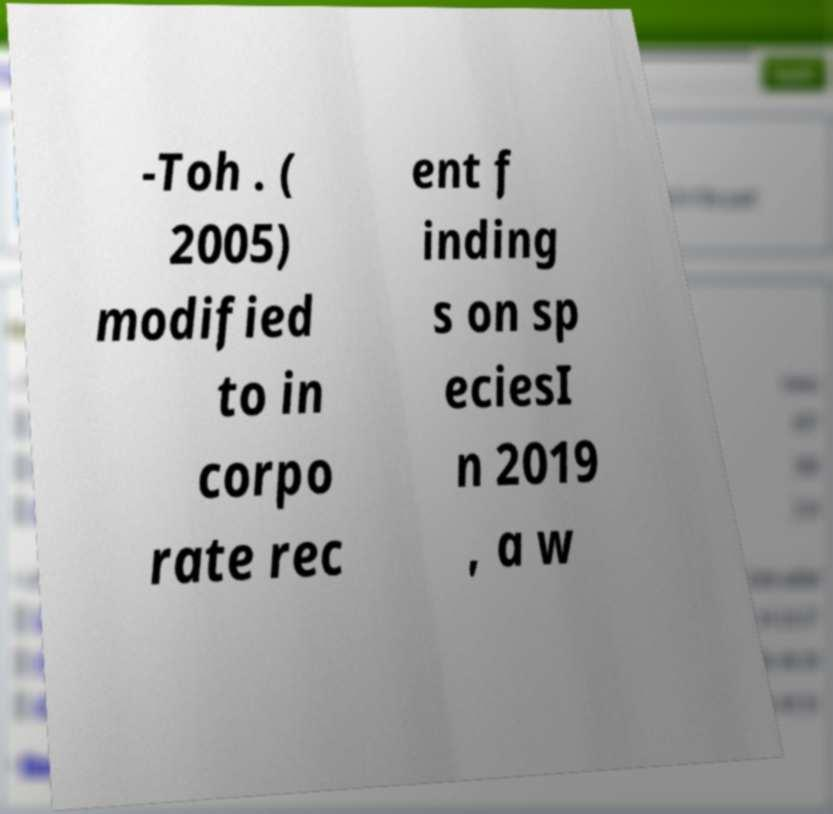Please read and relay the text visible in this image. What does it say? -Toh . ( 2005) modified to in corpo rate rec ent f inding s on sp eciesI n 2019 , a w 